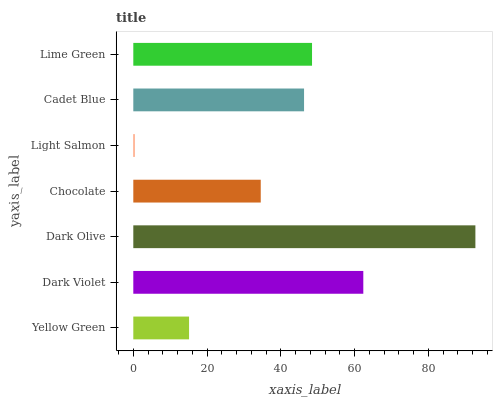Is Light Salmon the minimum?
Answer yes or no. Yes. Is Dark Olive the maximum?
Answer yes or no. Yes. Is Dark Violet the minimum?
Answer yes or no. No. Is Dark Violet the maximum?
Answer yes or no. No. Is Dark Violet greater than Yellow Green?
Answer yes or no. Yes. Is Yellow Green less than Dark Violet?
Answer yes or no. Yes. Is Yellow Green greater than Dark Violet?
Answer yes or no. No. Is Dark Violet less than Yellow Green?
Answer yes or no. No. Is Cadet Blue the high median?
Answer yes or no. Yes. Is Cadet Blue the low median?
Answer yes or no. Yes. Is Yellow Green the high median?
Answer yes or no. No. Is Dark Violet the low median?
Answer yes or no. No. 